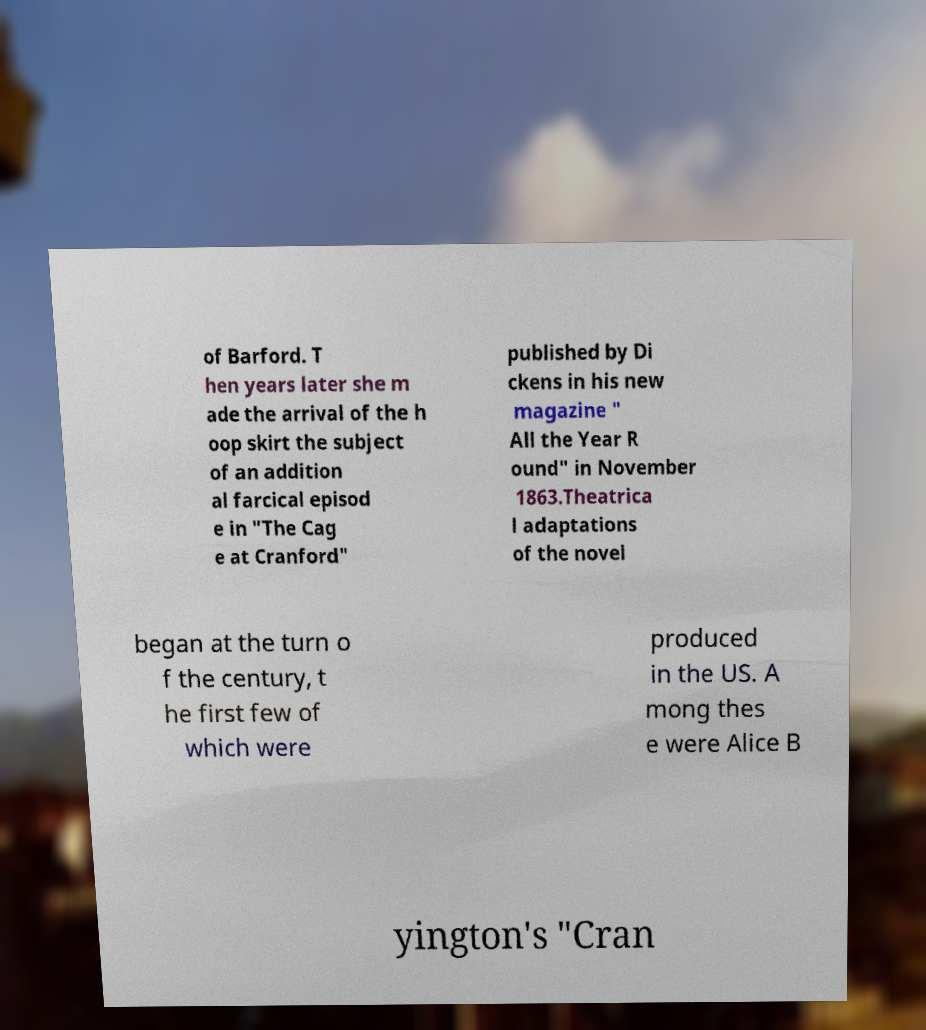There's text embedded in this image that I need extracted. Can you transcribe it verbatim? of Barford. T hen years later she m ade the arrival of the h oop skirt the subject of an addition al farcical episod e in "The Cag e at Cranford" published by Di ckens in his new magazine " All the Year R ound" in November 1863.Theatrica l adaptations of the novel began at the turn o f the century, t he first few of which were produced in the US. A mong thes e were Alice B yington's "Cran 